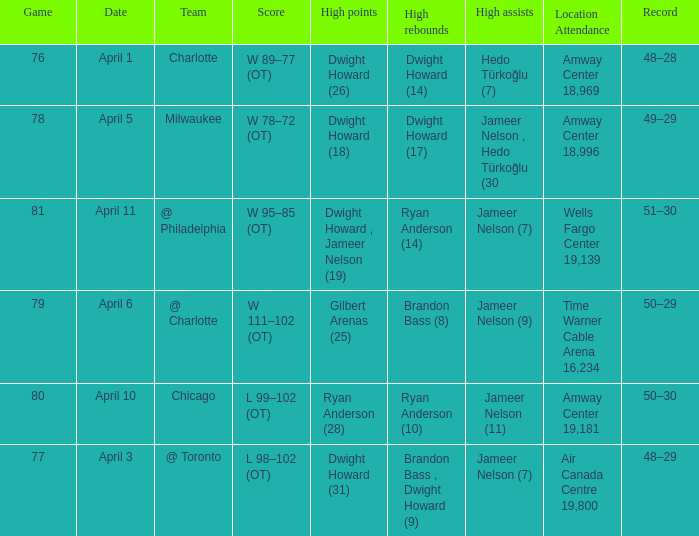Where was the game and what was the attendance on April 3?  Air Canada Centre 19,800. 